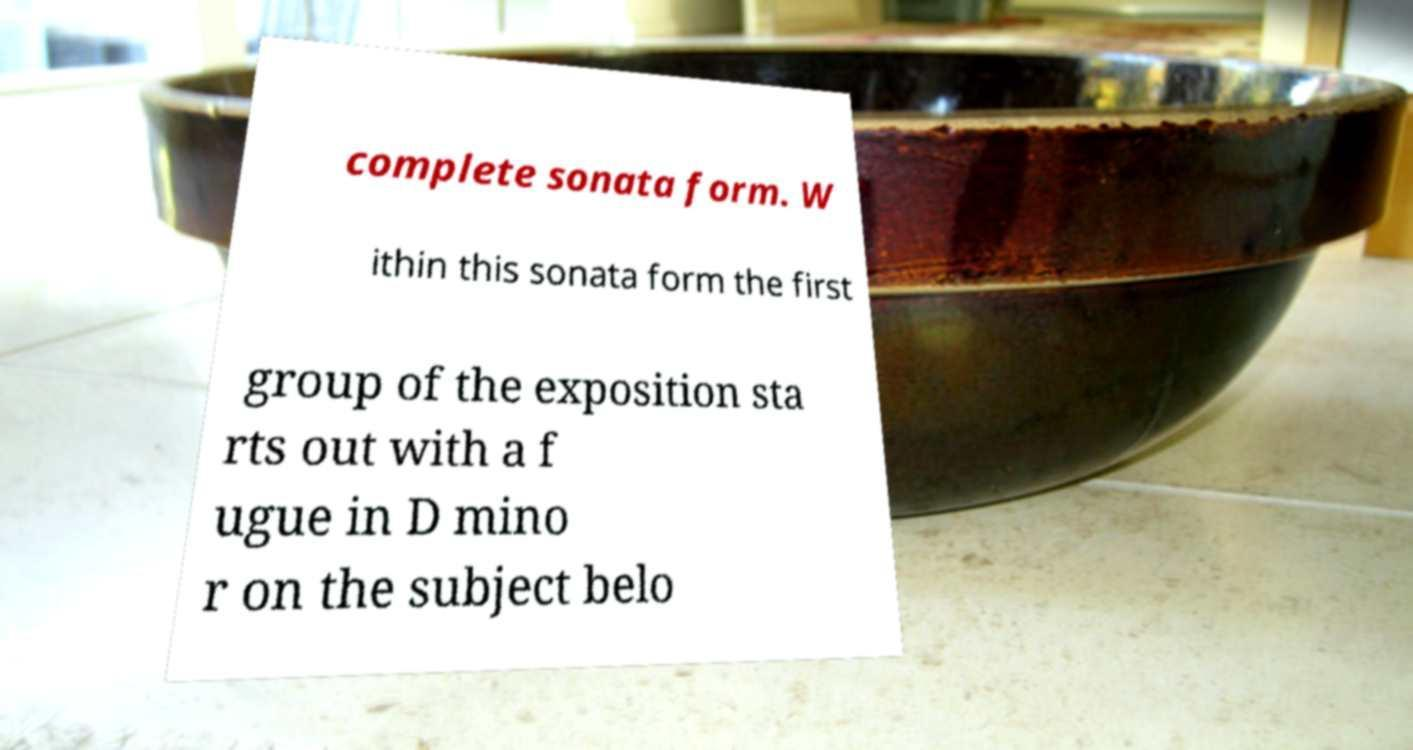Please identify and transcribe the text found in this image. complete sonata form. W ithin this sonata form the first group of the exposition sta rts out with a f ugue in D mino r on the subject belo 